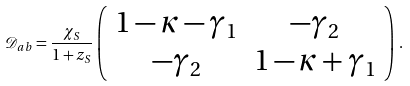Convert formula to latex. <formula><loc_0><loc_0><loc_500><loc_500>\mathcal { D } _ { a b } = \frac { \chi _ { S } } { 1 + z _ { S } } \left ( \begin{array} { c c } 1 - \kappa - \gamma _ { 1 } & - \gamma _ { 2 } \\ - \gamma _ { 2 } & 1 - \kappa + \gamma _ { 1 } \end{array} \right ) \, .</formula> 